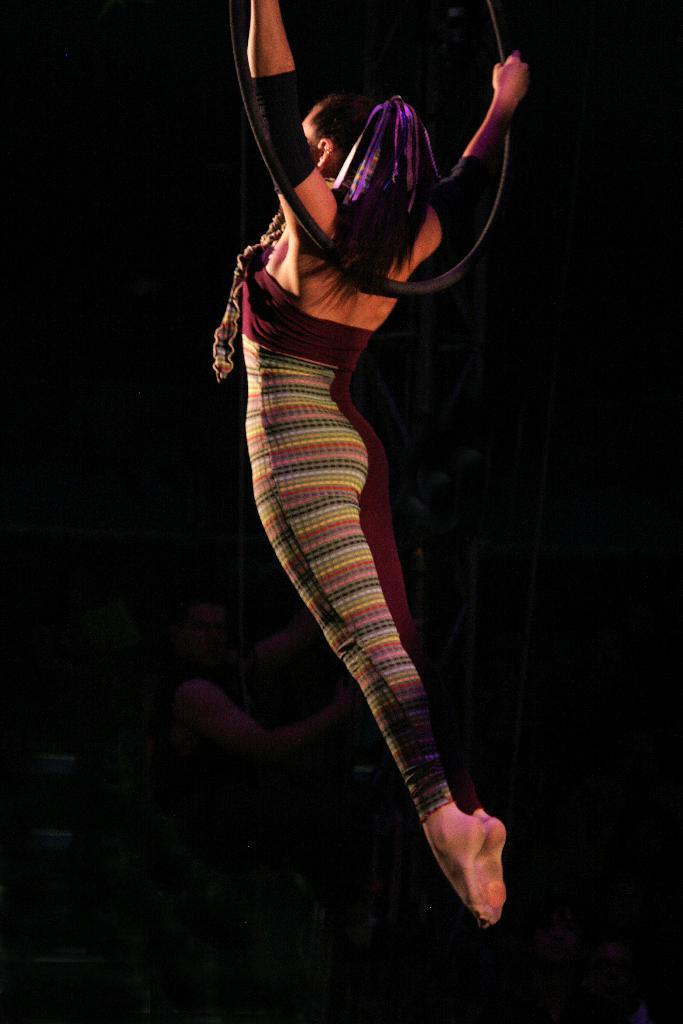Please provide a concise description of this image. In the image in the center we can see one woman performing and she is holding some round and black color object. 